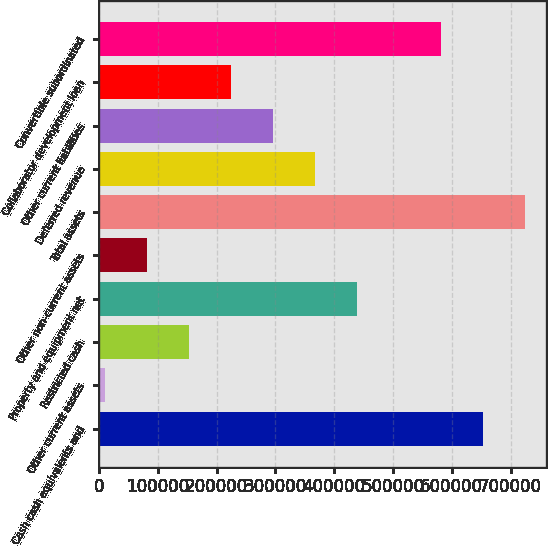Convert chart. <chart><loc_0><loc_0><loc_500><loc_500><bar_chart><fcel>Cash cash equivalents and<fcel>Other current assets<fcel>Restricted cash<fcel>Property and equipment net<fcel>Other non-current assets<fcel>Total assets<fcel>Deferred revenue<fcel>Other current liabilities<fcel>Collaborator development loan<fcel>Convertible subordinated<nl><fcel>653034<fcel>10642<fcel>153396<fcel>438903<fcel>82018.9<fcel>724411<fcel>367526<fcel>296150<fcel>224773<fcel>581657<nl></chart> 